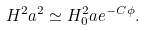<formula> <loc_0><loc_0><loc_500><loc_500>H ^ { 2 } a ^ { 2 } \simeq H _ { 0 } ^ { 2 } a e ^ { - C \phi } .</formula> 